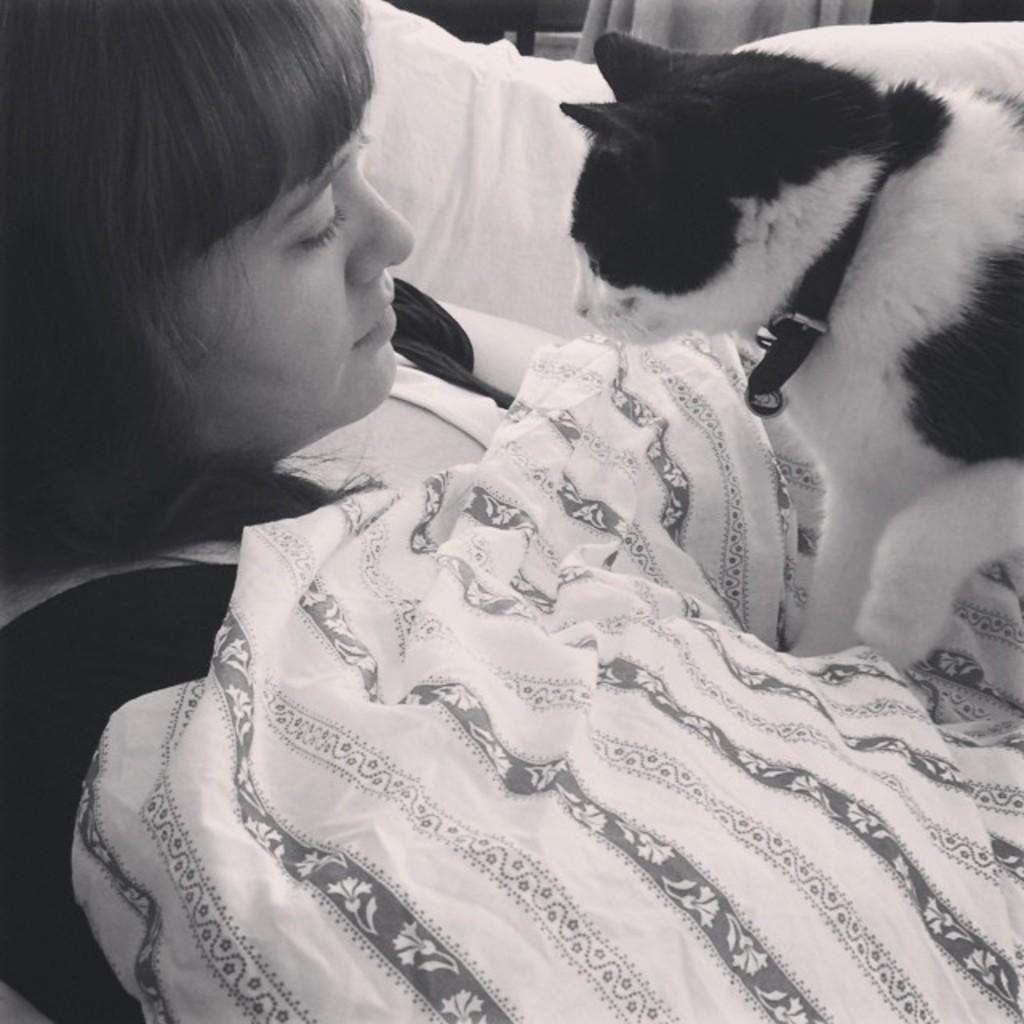What is the woman in the image doing? There is a woman lying on a couch in the image. Is there any other living creature present in the image? Yes, there is a cat on the woman. What type of wood can be seen in the image? There is no wood present in the image. What is the visibility of the surrounding environment like in the image? The visibility of the surrounding environment is not mentioned in the provided facts, so it cannot be determined from the image. 